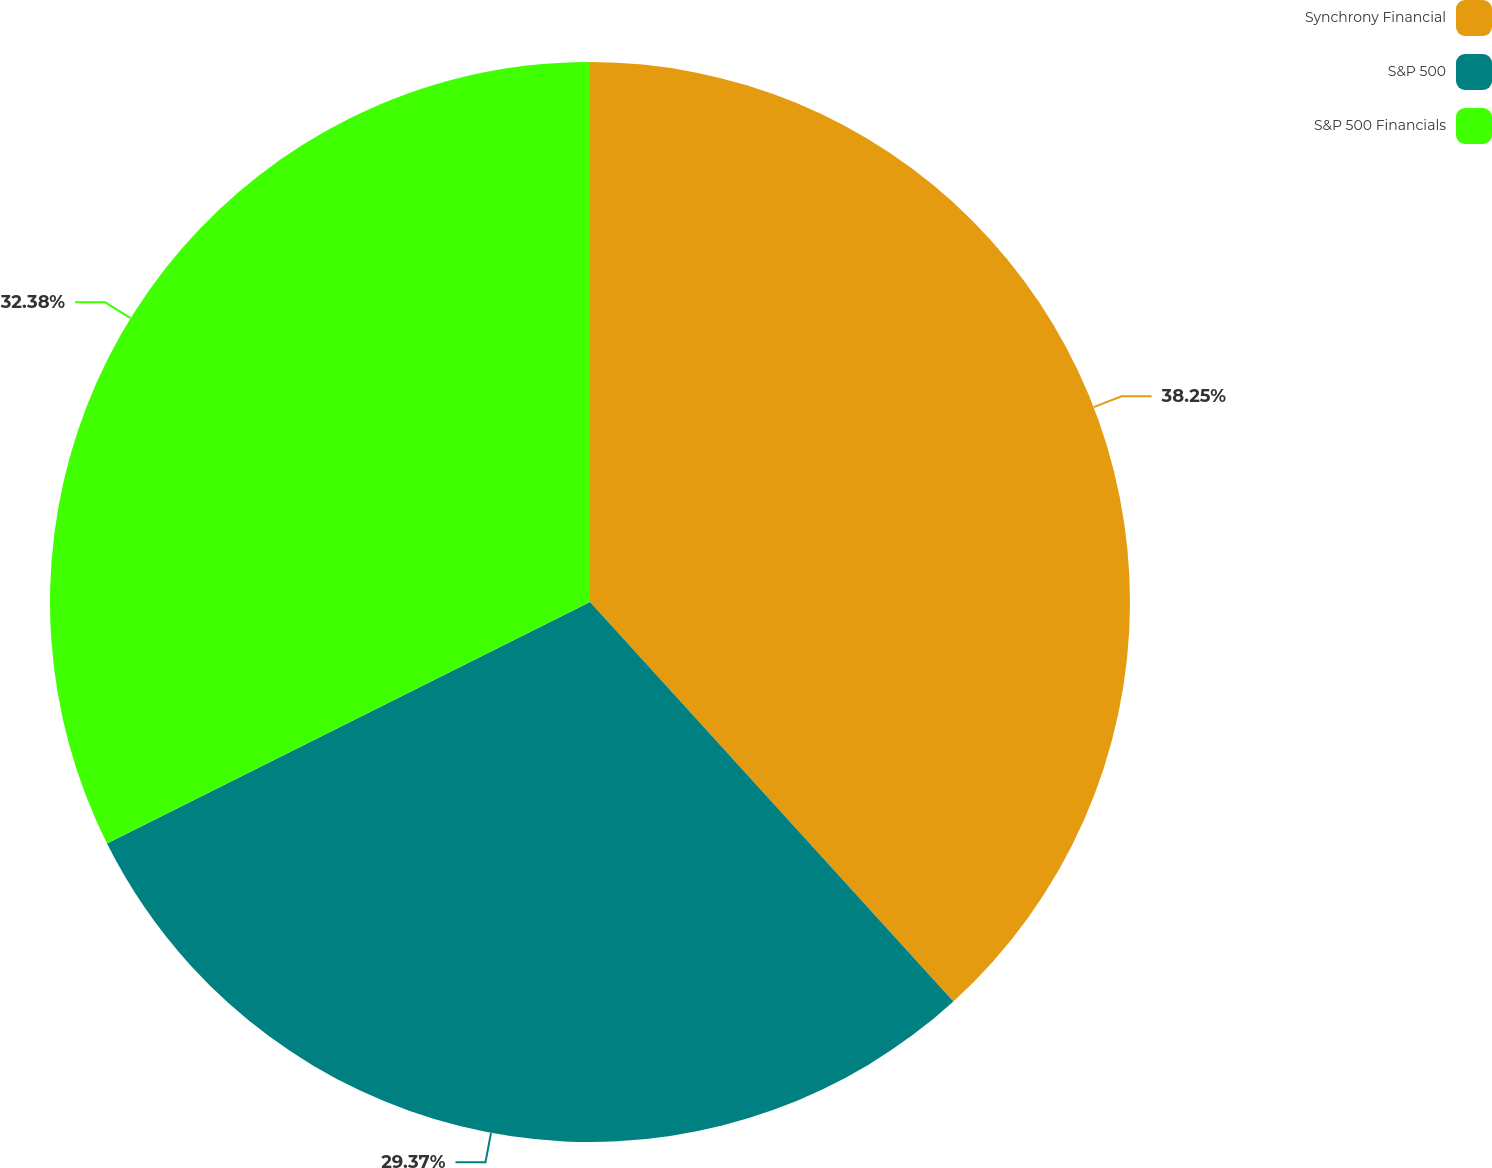<chart> <loc_0><loc_0><loc_500><loc_500><pie_chart><fcel>Synchrony Financial<fcel>S&P 500<fcel>S&P 500 Financials<nl><fcel>38.25%<fcel>29.37%<fcel>32.38%<nl></chart> 